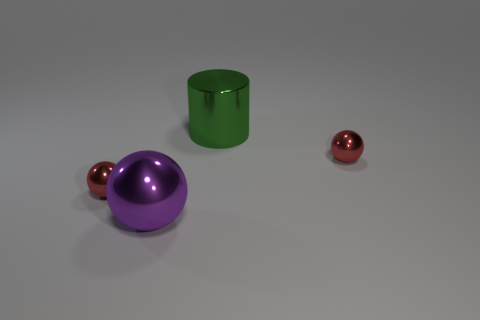Is there anything distinct about the positioning of these objects? The objects are spaced apart in a manner that seems intentional and could suggest a deliberate composition, perhaps to emphasize their shapes and colors. 